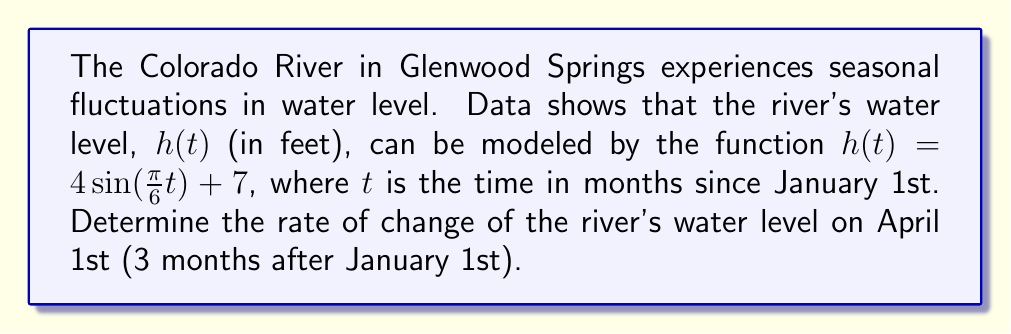Could you help me with this problem? To find the rate of change of the river's water level, we need to calculate the derivative of $h(t)$ and evaluate it at $t=3$ (April 1st).

1) The given function is $h(t) = 4\sin(\frac{\pi}{6}t) + 7$

2) To find $\frac{dh}{dt}$, we use the chain rule:
   $$\frac{dh}{dt} = 4 \cdot \frac{d}{dt}[\sin(\frac{\pi}{6}t)] + \frac{d}{dt}[7]$$

3) Using the chain rule and the fact that $\frac{d}{dt}[\sin(x)] = \cos(x)$:
   $$\frac{dh}{dt} = 4 \cdot \cos(\frac{\pi}{6}t) \cdot \frac{\pi}{6} + 0$$

4) Simplify:
   $$\frac{dh}{dt} = \frac{2\pi}{3}\cos(\frac{\pi}{6}t)$$

5) Now, evaluate at $t=3$:
   $$\frac{dh}{dt}\bigg|_{t=3} = \frac{2\pi}{3}\cos(\frac{\pi}{6} \cdot 3)$$

6) Simplify:
   $$\frac{dh}{dt}\bigg|_{t=3} = \frac{2\pi}{3}\cos(\frac{\pi}{2}) = \frac{2\pi}{3} \cdot 0 = 0$$

The rate of change of the river's water level on April 1st is 0 ft/month.
Answer: 0 ft/month 